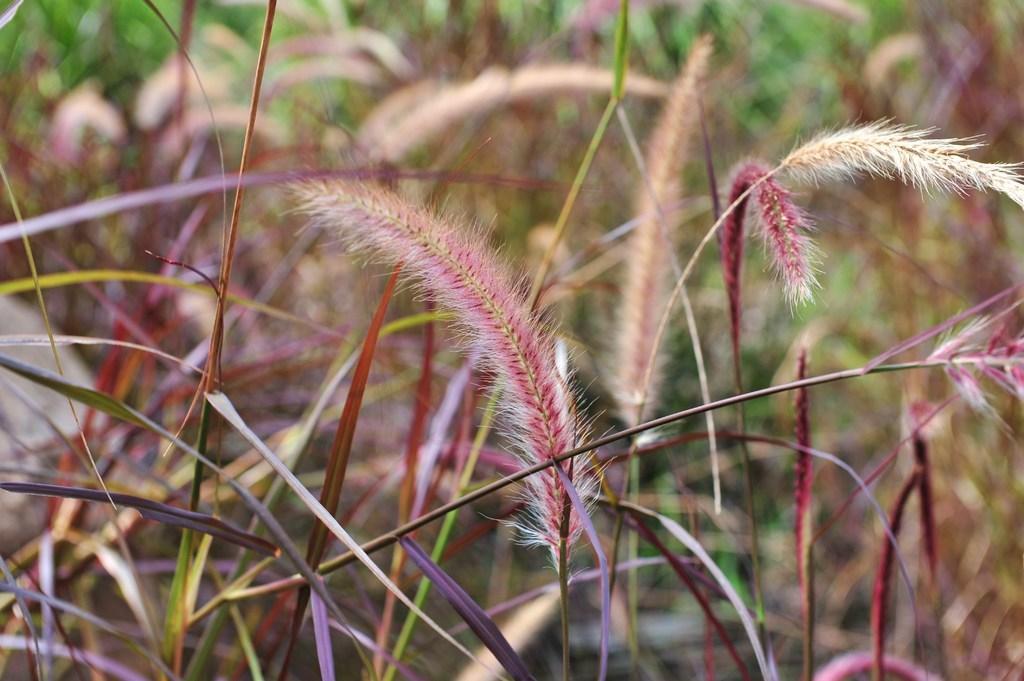How would you summarize this image in a sentence or two? In this picture I can see number of plants and I see that it is blurred in the background. 